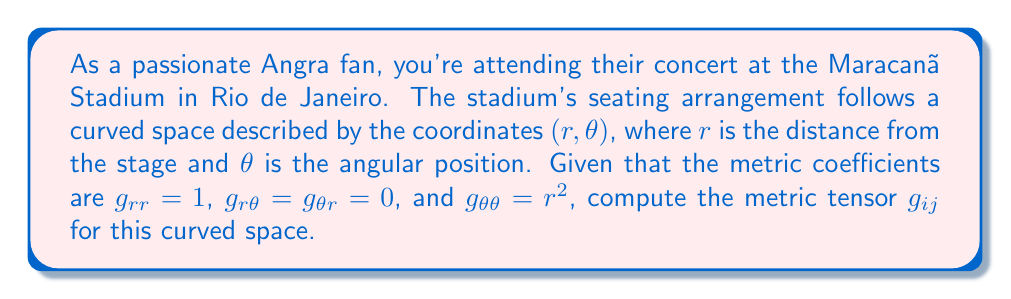Show me your answer to this math problem. To compute the metric tensor for the curved space of the stadium seating arrangement, we follow these steps:

1) The metric tensor $g_{ij}$ is a symmetric 2x2 matrix in this case, as we have two coordinates $(r, \theta)$.

2) The components of the metric tensor are given by:
   $g_{rr} = 1$
   $g_{r\theta} = g_{\theta r} = 0$
   $g_{\theta\theta} = r^2$

3) We can represent this as a matrix:

   $$g_{ij} = \begin{pmatrix}
   g_{rr} & g_{r\theta} \\
   g_{\theta r} & g_{\theta\theta}
   \end{pmatrix}$$

4) Substituting the given values:

   $$g_{ij} = \begin{pmatrix}
   1 & 0 \\
   0 & r^2
   \end{pmatrix}$$

This matrix represents the metric tensor for the curved space of the stadium seating arrangement.
Answer: $$g_{ij} = \begin{pmatrix}
1 & 0 \\
0 & r^2
\end{pmatrix}$$ 